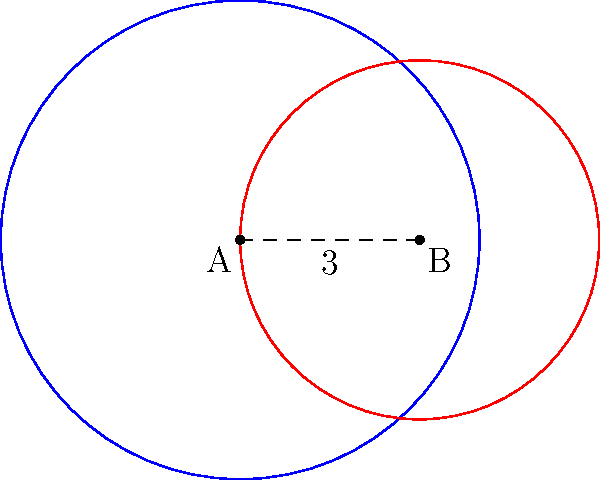Two grassroots organizations, A and B, have spheres of influence represented by circular regions. Organization A's influence extends 4 units from its center, while organization B's influence extends 3 units. The centers of these regions are 3 units apart. Calculate the area of overlap between these two spheres of influence, representing the population affected by both organizations. Round your answer to two decimal places. To find the area of overlap between two circles, we can use the formula for the area of intersection:

$$A = r_1^2 \arccos(\frac{d^2 + r_1^2 - r_2^2}{2dr_1}) + r_2^2 \arccos(\frac{d^2 + r_2^2 - r_1^2}{2dr_2}) - \frac{1}{2}\sqrt{(-d+r_1+r_2)(d+r_1-r_2)(d-r_1+r_2)(d+r_1+r_2)}$$

Where:
$r_1$ = radius of circle A = 4
$r_2$ = radius of circle B = 3
$d$ = distance between centers = 3

Step 1: Calculate the first term
$$r_1^2 \arccos(\frac{d^2 + r_1^2 - r_2^2}{2dr_1}) = 16 \arccos(\frac{9 + 16 - 9}{2 * 3 * 4}) = 16 \arccos(\frac{16}{24}) = 16 * 0.7297 = 11.6752$$

Step 2: Calculate the second term
$$r_2^2 \arccos(\frac{d^2 + r_2^2 - r_1^2}{2dr_2}) = 9 \arccos(\frac{9 + 9 - 16}{2 * 3 * 3}) = 9 \arccos(\frac{2}{18}) = 9 * 1.4706 = 13.2354$$

Step 3: Calculate the third term
$$\frac{1}{2}\sqrt{(-d+r_1+r_2)(d+r_1-r_2)(d-r_1+r_2)(d+r_1+r_2)} = \frac{1}{2}\sqrt{(4)(4)(2)(10)} = \frac{1}{2}\sqrt{320} = 8.9443$$

Step 4: Sum up the terms
$$A = 11.6752 + 13.2354 - 8.9443 = 15.9663$$

Step 5: Round to two decimal places
$$A \approx 15.97$$
Answer: 15.97 square units 